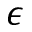<formula> <loc_0><loc_0><loc_500><loc_500>\epsilon</formula> 